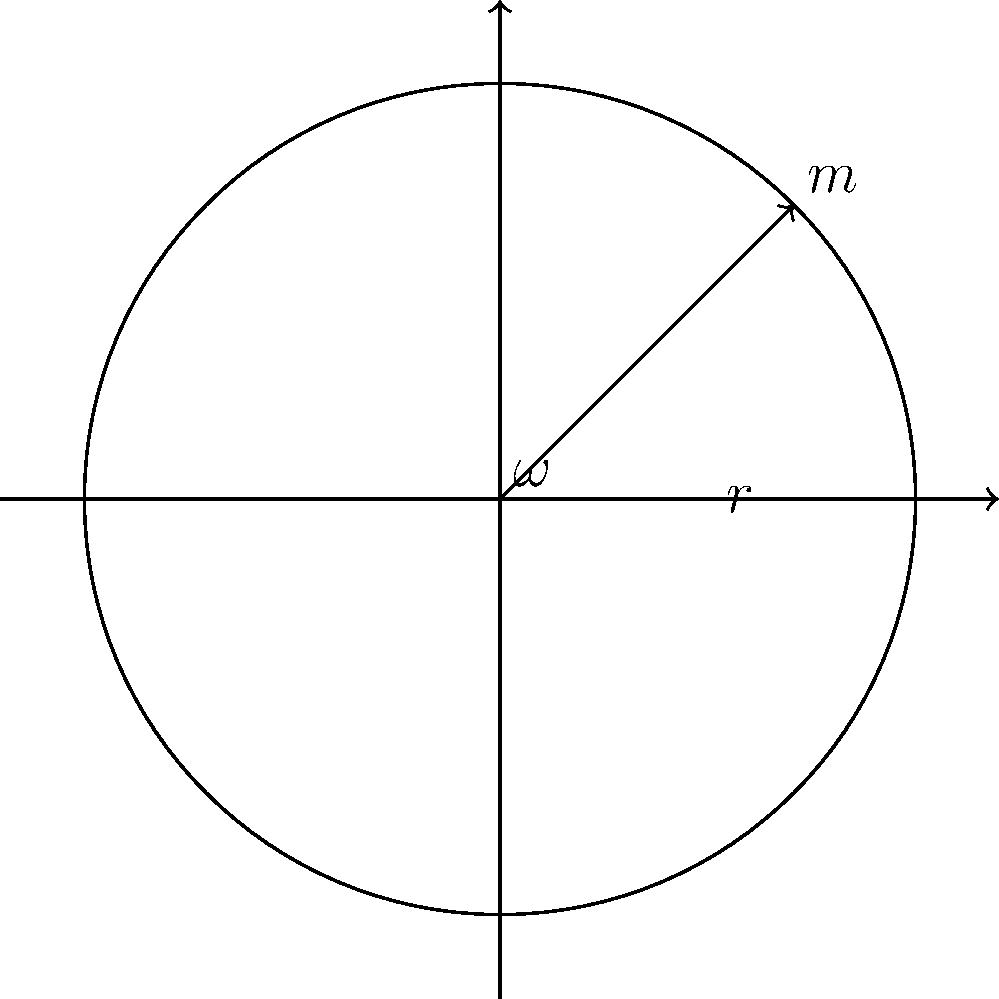A flywheel energy storage system consists of a solid disc with mass $m = 500$ kg and radius $r = 1.5$ m. If the flywheel is spinning at an angular velocity $\omega = 300$ rad/s, calculate the potential energy stored in the system. Assume the flywheel can be treated as a thin rim where all the mass is concentrated at the outer edge. To solve this problem, we'll follow these steps:

1) The formula for rotational kinetic energy (which is equivalent to the potential energy stored in the system) is:

   $E = \frac{1}{2}I\omega^2$

   Where $E$ is energy, $I$ is moment of inertia, and $\omega$ is angular velocity.

2) For a thin rim, the moment of inertia $I$ is given by:

   $I = mr^2$

   Where $m$ is mass and $r$ is radius.

3) Let's calculate the moment of inertia:

   $I = 500 \text{ kg} \cdot (1.5 \text{ m})^2 = 1125 \text{ kg}\cdot\text{m}^2$

4) Now we can substitute this into our energy equation:

   $E = \frac{1}{2} \cdot 1125 \text{ kg}\cdot\text{m}^2 \cdot (300 \text{ rad/s})^2$

5) Simplify:

   $E = \frac{1}{2} \cdot 1125 \cdot 90000 \text{ J} = 50,625,000 \text{ J}$

6) Convert to megajoules:

   $E = 50.625 \text{ MJ}$

Therefore, the potential energy stored in the flywheel energy storage system is 50.625 MJ.
Answer: 50.625 MJ 